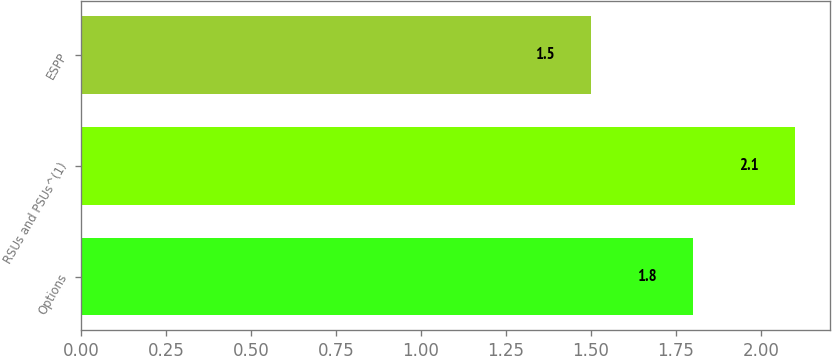Convert chart. <chart><loc_0><loc_0><loc_500><loc_500><bar_chart><fcel>Options<fcel>RSUs and PSUs^(1)<fcel>ESPP<nl><fcel>1.8<fcel>2.1<fcel>1.5<nl></chart> 